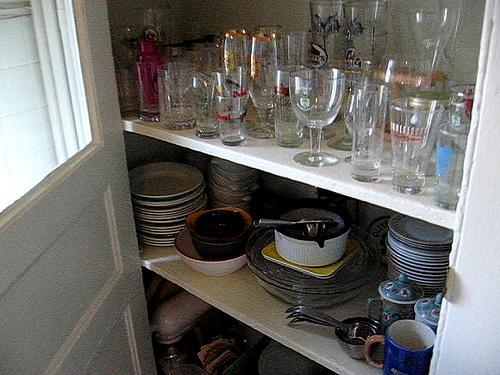Where are these items being stored? Please explain your reasoning. cabinet. It's also likely a kitchen one. 